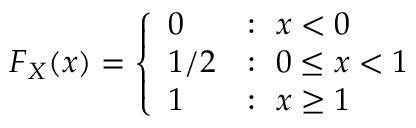<formula> <loc_0><loc_0><loc_500><loc_500>F _ { X } ( x ) = { \left \{ \begin{array} { l l } { 0 } & { \colon \ x < 0 } \\ { 1 / 2 } & { \colon \ 0 \leq x < 1 } \\ { 1 } & { \colon \ x \geq 1 } \end{array} }</formula> 